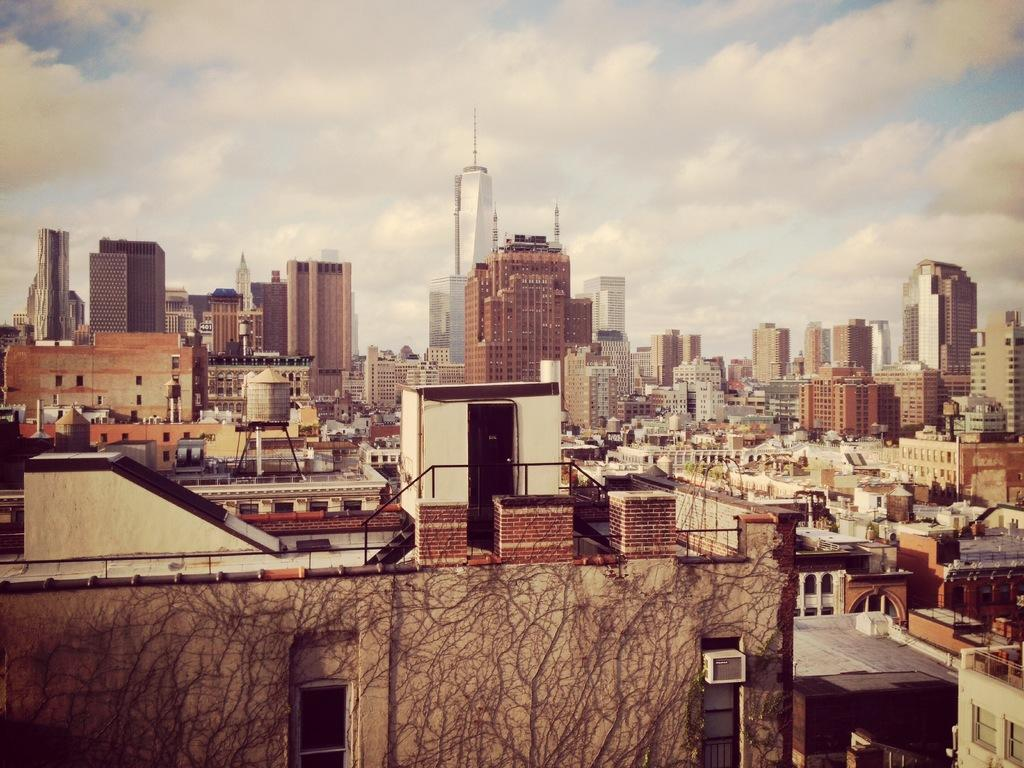What type of view is shown in the image? The image is an aerial view of a city. What can be seen in the city? There are many buildings in the city. What is visible in the background of the image? The sky is visible in the image. What is the condition of the sky in the image? Clouds are present in the sky. What word is being used to describe the bushes in the image? There are no bushes present in the image, so there is no word being used to describe them. What type of meeting is taking place in the image? There is no meeting taking place in the image; it is an aerial view of a city with many buildings and a sky with clouds. 